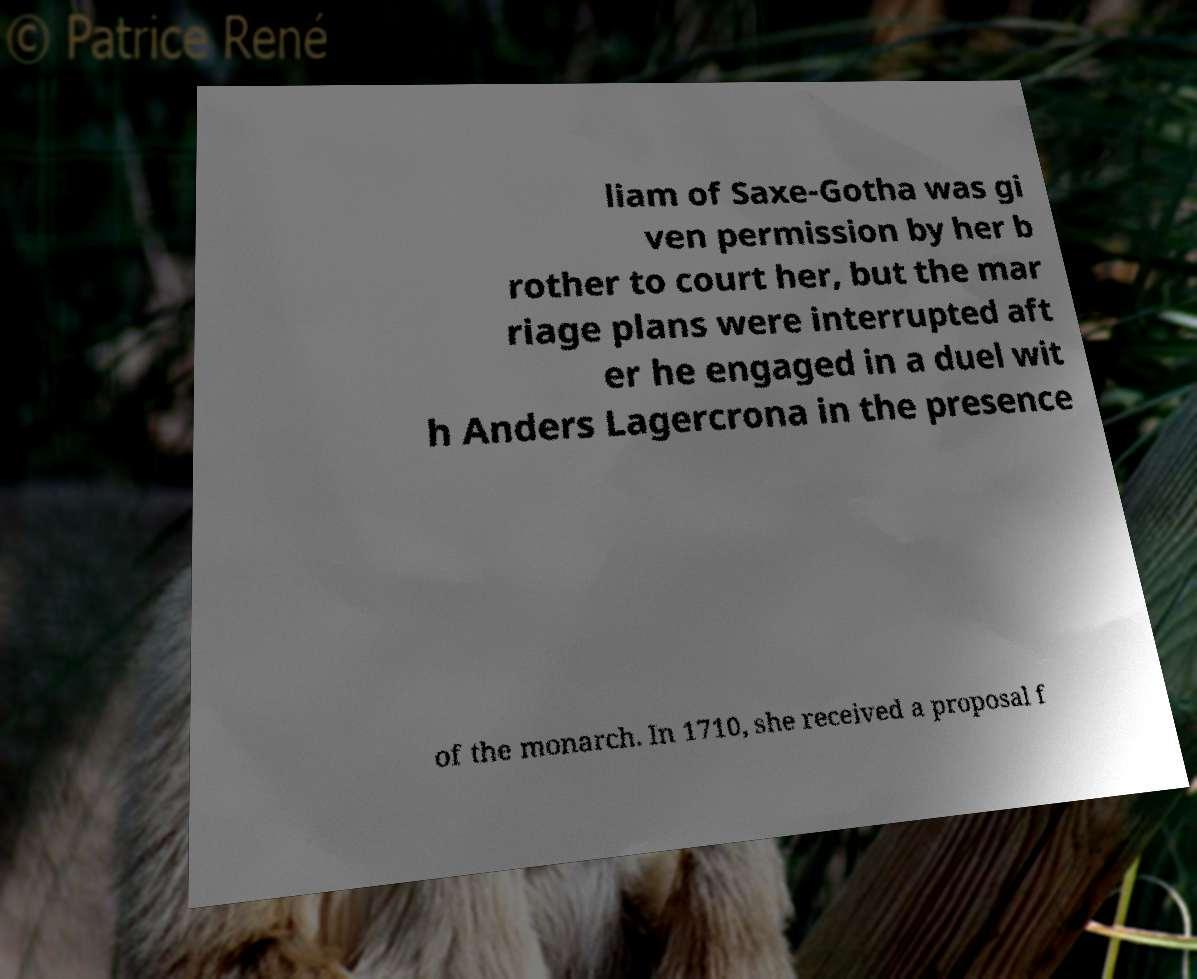Can you accurately transcribe the text from the provided image for me? liam of Saxe-Gotha was gi ven permission by her b rother to court her, but the mar riage plans were interrupted aft er he engaged in a duel wit h Anders Lagercrona in the presence of the monarch. In 1710, she received a proposal f 